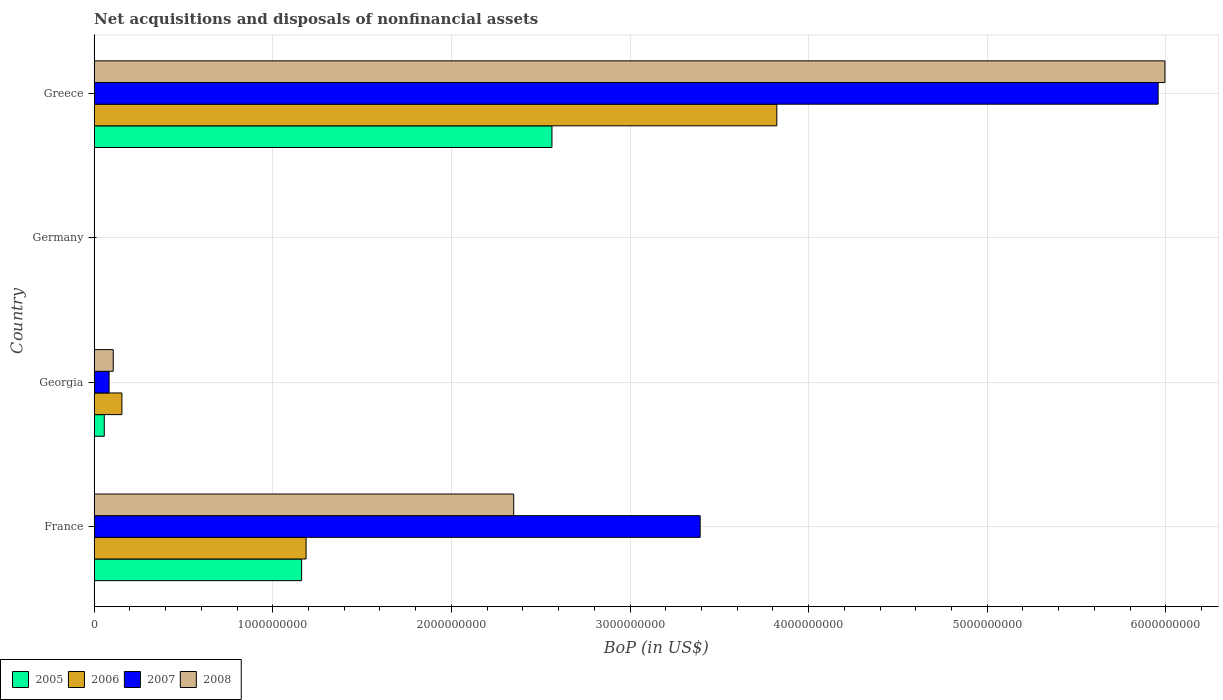How many different coloured bars are there?
Offer a very short reply. 4. Are the number of bars per tick equal to the number of legend labels?
Give a very brief answer. No. Are the number of bars on each tick of the Y-axis equal?
Your answer should be very brief. No. How many bars are there on the 1st tick from the top?
Ensure brevity in your answer.  4. What is the label of the 2nd group of bars from the top?
Make the answer very short. Germany. What is the Balance of Payments in 2007 in Germany?
Offer a very short reply. 0. Across all countries, what is the maximum Balance of Payments in 2008?
Offer a very short reply. 6.00e+09. What is the total Balance of Payments in 2008 in the graph?
Provide a succinct answer. 8.45e+09. What is the difference between the Balance of Payments in 2005 in Georgia and that in Greece?
Your response must be concise. -2.51e+09. What is the difference between the Balance of Payments in 2005 in Greece and the Balance of Payments in 2008 in Germany?
Offer a terse response. 2.56e+09. What is the average Balance of Payments in 2007 per country?
Offer a terse response. 2.36e+09. What is the difference between the Balance of Payments in 2007 and Balance of Payments in 2005 in France?
Offer a very short reply. 2.23e+09. What is the ratio of the Balance of Payments in 2007 in Georgia to that in Greece?
Ensure brevity in your answer.  0.01. Is the difference between the Balance of Payments in 2007 in Georgia and Greece greater than the difference between the Balance of Payments in 2005 in Georgia and Greece?
Offer a terse response. No. What is the difference between the highest and the second highest Balance of Payments in 2005?
Provide a succinct answer. 1.40e+09. What is the difference between the highest and the lowest Balance of Payments in 2005?
Your answer should be compact. 2.56e+09. In how many countries, is the Balance of Payments in 2007 greater than the average Balance of Payments in 2007 taken over all countries?
Ensure brevity in your answer.  2. Is the sum of the Balance of Payments in 2006 in Georgia and Greece greater than the maximum Balance of Payments in 2005 across all countries?
Keep it short and to the point. Yes. Is it the case that in every country, the sum of the Balance of Payments in 2008 and Balance of Payments in 2007 is greater than the sum of Balance of Payments in 2005 and Balance of Payments in 2006?
Your response must be concise. No. Is it the case that in every country, the sum of the Balance of Payments in 2007 and Balance of Payments in 2006 is greater than the Balance of Payments in 2008?
Make the answer very short. No. How many bars are there?
Your response must be concise. 12. Are all the bars in the graph horizontal?
Give a very brief answer. Yes. Are the values on the major ticks of X-axis written in scientific E-notation?
Your answer should be very brief. No. Does the graph contain grids?
Offer a terse response. Yes. How many legend labels are there?
Provide a short and direct response. 4. What is the title of the graph?
Your answer should be compact. Net acquisitions and disposals of nonfinancial assets. Does "2005" appear as one of the legend labels in the graph?
Provide a short and direct response. Yes. What is the label or title of the X-axis?
Your answer should be compact. BoP (in US$). What is the BoP (in US$) of 2005 in France?
Offer a very short reply. 1.16e+09. What is the BoP (in US$) in 2006 in France?
Provide a succinct answer. 1.19e+09. What is the BoP (in US$) of 2007 in France?
Your answer should be compact. 3.39e+09. What is the BoP (in US$) in 2008 in France?
Offer a terse response. 2.35e+09. What is the BoP (in US$) of 2005 in Georgia?
Offer a very short reply. 5.65e+07. What is the BoP (in US$) in 2006 in Georgia?
Offer a terse response. 1.55e+08. What is the BoP (in US$) in 2007 in Georgia?
Offer a very short reply. 8.34e+07. What is the BoP (in US$) of 2008 in Georgia?
Keep it short and to the point. 1.07e+08. What is the BoP (in US$) of 2005 in Germany?
Keep it short and to the point. 0. What is the BoP (in US$) in 2005 in Greece?
Your answer should be compact. 2.56e+09. What is the BoP (in US$) of 2006 in Greece?
Offer a terse response. 3.82e+09. What is the BoP (in US$) in 2007 in Greece?
Your response must be concise. 5.96e+09. What is the BoP (in US$) of 2008 in Greece?
Offer a very short reply. 6.00e+09. Across all countries, what is the maximum BoP (in US$) of 2005?
Your response must be concise. 2.56e+09. Across all countries, what is the maximum BoP (in US$) in 2006?
Make the answer very short. 3.82e+09. Across all countries, what is the maximum BoP (in US$) of 2007?
Provide a short and direct response. 5.96e+09. Across all countries, what is the maximum BoP (in US$) of 2008?
Offer a terse response. 6.00e+09. Across all countries, what is the minimum BoP (in US$) of 2006?
Give a very brief answer. 0. Across all countries, what is the minimum BoP (in US$) in 2007?
Provide a short and direct response. 0. What is the total BoP (in US$) of 2005 in the graph?
Your response must be concise. 3.78e+09. What is the total BoP (in US$) of 2006 in the graph?
Provide a short and direct response. 5.16e+09. What is the total BoP (in US$) in 2007 in the graph?
Provide a short and direct response. 9.43e+09. What is the total BoP (in US$) of 2008 in the graph?
Keep it short and to the point. 8.45e+09. What is the difference between the BoP (in US$) of 2005 in France and that in Georgia?
Provide a short and direct response. 1.10e+09. What is the difference between the BoP (in US$) of 2006 in France and that in Georgia?
Your answer should be very brief. 1.03e+09. What is the difference between the BoP (in US$) of 2007 in France and that in Georgia?
Ensure brevity in your answer.  3.31e+09. What is the difference between the BoP (in US$) in 2008 in France and that in Georgia?
Provide a succinct answer. 2.24e+09. What is the difference between the BoP (in US$) in 2005 in France and that in Greece?
Ensure brevity in your answer.  -1.40e+09. What is the difference between the BoP (in US$) of 2006 in France and that in Greece?
Ensure brevity in your answer.  -2.64e+09. What is the difference between the BoP (in US$) of 2007 in France and that in Greece?
Provide a succinct answer. -2.56e+09. What is the difference between the BoP (in US$) of 2008 in France and that in Greece?
Offer a very short reply. -3.65e+09. What is the difference between the BoP (in US$) of 2005 in Georgia and that in Greece?
Give a very brief answer. -2.51e+09. What is the difference between the BoP (in US$) of 2006 in Georgia and that in Greece?
Ensure brevity in your answer.  -3.67e+09. What is the difference between the BoP (in US$) of 2007 in Georgia and that in Greece?
Provide a short and direct response. -5.87e+09. What is the difference between the BoP (in US$) of 2008 in Georgia and that in Greece?
Give a very brief answer. -5.89e+09. What is the difference between the BoP (in US$) in 2005 in France and the BoP (in US$) in 2006 in Georgia?
Keep it short and to the point. 1.01e+09. What is the difference between the BoP (in US$) of 2005 in France and the BoP (in US$) of 2007 in Georgia?
Provide a short and direct response. 1.08e+09. What is the difference between the BoP (in US$) in 2005 in France and the BoP (in US$) in 2008 in Georgia?
Provide a short and direct response. 1.05e+09. What is the difference between the BoP (in US$) of 2006 in France and the BoP (in US$) of 2007 in Georgia?
Provide a short and direct response. 1.10e+09. What is the difference between the BoP (in US$) in 2006 in France and the BoP (in US$) in 2008 in Georgia?
Your answer should be very brief. 1.08e+09. What is the difference between the BoP (in US$) in 2007 in France and the BoP (in US$) in 2008 in Georgia?
Your answer should be very brief. 3.29e+09. What is the difference between the BoP (in US$) in 2005 in France and the BoP (in US$) in 2006 in Greece?
Offer a terse response. -2.66e+09. What is the difference between the BoP (in US$) of 2005 in France and the BoP (in US$) of 2007 in Greece?
Provide a succinct answer. -4.80e+09. What is the difference between the BoP (in US$) in 2005 in France and the BoP (in US$) in 2008 in Greece?
Your response must be concise. -4.83e+09. What is the difference between the BoP (in US$) in 2006 in France and the BoP (in US$) in 2007 in Greece?
Provide a short and direct response. -4.77e+09. What is the difference between the BoP (in US$) of 2006 in France and the BoP (in US$) of 2008 in Greece?
Your answer should be compact. -4.81e+09. What is the difference between the BoP (in US$) of 2007 in France and the BoP (in US$) of 2008 in Greece?
Offer a terse response. -2.60e+09. What is the difference between the BoP (in US$) of 2005 in Georgia and the BoP (in US$) of 2006 in Greece?
Give a very brief answer. -3.77e+09. What is the difference between the BoP (in US$) of 2005 in Georgia and the BoP (in US$) of 2007 in Greece?
Your response must be concise. -5.90e+09. What is the difference between the BoP (in US$) of 2005 in Georgia and the BoP (in US$) of 2008 in Greece?
Provide a succinct answer. -5.94e+09. What is the difference between the BoP (in US$) of 2006 in Georgia and the BoP (in US$) of 2007 in Greece?
Your answer should be very brief. -5.80e+09. What is the difference between the BoP (in US$) of 2006 in Georgia and the BoP (in US$) of 2008 in Greece?
Make the answer very short. -5.84e+09. What is the difference between the BoP (in US$) of 2007 in Georgia and the BoP (in US$) of 2008 in Greece?
Provide a succinct answer. -5.91e+09. What is the average BoP (in US$) of 2005 per country?
Make the answer very short. 9.45e+08. What is the average BoP (in US$) of 2006 per country?
Keep it short and to the point. 1.29e+09. What is the average BoP (in US$) of 2007 per country?
Your answer should be very brief. 2.36e+09. What is the average BoP (in US$) of 2008 per country?
Provide a succinct answer. 2.11e+09. What is the difference between the BoP (in US$) in 2005 and BoP (in US$) in 2006 in France?
Give a very brief answer. -2.51e+07. What is the difference between the BoP (in US$) in 2005 and BoP (in US$) in 2007 in France?
Keep it short and to the point. -2.23e+09. What is the difference between the BoP (in US$) in 2005 and BoP (in US$) in 2008 in France?
Offer a terse response. -1.19e+09. What is the difference between the BoP (in US$) in 2006 and BoP (in US$) in 2007 in France?
Provide a short and direct response. -2.21e+09. What is the difference between the BoP (in US$) in 2006 and BoP (in US$) in 2008 in France?
Your response must be concise. -1.16e+09. What is the difference between the BoP (in US$) of 2007 and BoP (in US$) of 2008 in France?
Ensure brevity in your answer.  1.04e+09. What is the difference between the BoP (in US$) in 2005 and BoP (in US$) in 2006 in Georgia?
Offer a very short reply. -9.86e+07. What is the difference between the BoP (in US$) in 2005 and BoP (in US$) in 2007 in Georgia?
Ensure brevity in your answer.  -2.69e+07. What is the difference between the BoP (in US$) in 2005 and BoP (in US$) in 2008 in Georgia?
Provide a succinct answer. -5.01e+07. What is the difference between the BoP (in US$) in 2006 and BoP (in US$) in 2007 in Georgia?
Offer a very short reply. 7.17e+07. What is the difference between the BoP (in US$) of 2006 and BoP (in US$) of 2008 in Georgia?
Keep it short and to the point. 4.85e+07. What is the difference between the BoP (in US$) in 2007 and BoP (in US$) in 2008 in Georgia?
Provide a short and direct response. -2.32e+07. What is the difference between the BoP (in US$) of 2005 and BoP (in US$) of 2006 in Greece?
Keep it short and to the point. -1.26e+09. What is the difference between the BoP (in US$) in 2005 and BoP (in US$) in 2007 in Greece?
Offer a very short reply. -3.39e+09. What is the difference between the BoP (in US$) in 2005 and BoP (in US$) in 2008 in Greece?
Make the answer very short. -3.43e+09. What is the difference between the BoP (in US$) in 2006 and BoP (in US$) in 2007 in Greece?
Offer a very short reply. -2.14e+09. What is the difference between the BoP (in US$) of 2006 and BoP (in US$) of 2008 in Greece?
Offer a terse response. -2.17e+09. What is the difference between the BoP (in US$) of 2007 and BoP (in US$) of 2008 in Greece?
Provide a succinct answer. -3.82e+07. What is the ratio of the BoP (in US$) of 2005 in France to that in Georgia?
Provide a short and direct response. 20.56. What is the ratio of the BoP (in US$) in 2006 in France to that in Georgia?
Make the answer very short. 7.65. What is the ratio of the BoP (in US$) of 2007 in France to that in Georgia?
Your answer should be very brief. 40.68. What is the ratio of the BoP (in US$) of 2008 in France to that in Georgia?
Your response must be concise. 22.03. What is the ratio of the BoP (in US$) of 2005 in France to that in Greece?
Provide a short and direct response. 0.45. What is the ratio of the BoP (in US$) in 2006 in France to that in Greece?
Offer a very short reply. 0.31. What is the ratio of the BoP (in US$) in 2007 in France to that in Greece?
Your answer should be very brief. 0.57. What is the ratio of the BoP (in US$) in 2008 in France to that in Greece?
Offer a very short reply. 0.39. What is the ratio of the BoP (in US$) of 2005 in Georgia to that in Greece?
Provide a succinct answer. 0.02. What is the ratio of the BoP (in US$) of 2006 in Georgia to that in Greece?
Your answer should be very brief. 0.04. What is the ratio of the BoP (in US$) of 2007 in Georgia to that in Greece?
Keep it short and to the point. 0.01. What is the ratio of the BoP (in US$) of 2008 in Georgia to that in Greece?
Your answer should be very brief. 0.02. What is the difference between the highest and the second highest BoP (in US$) in 2005?
Offer a terse response. 1.40e+09. What is the difference between the highest and the second highest BoP (in US$) of 2006?
Give a very brief answer. 2.64e+09. What is the difference between the highest and the second highest BoP (in US$) of 2007?
Your response must be concise. 2.56e+09. What is the difference between the highest and the second highest BoP (in US$) in 2008?
Offer a terse response. 3.65e+09. What is the difference between the highest and the lowest BoP (in US$) in 2005?
Your answer should be compact. 2.56e+09. What is the difference between the highest and the lowest BoP (in US$) in 2006?
Your answer should be compact. 3.82e+09. What is the difference between the highest and the lowest BoP (in US$) of 2007?
Offer a very short reply. 5.96e+09. What is the difference between the highest and the lowest BoP (in US$) of 2008?
Your response must be concise. 6.00e+09. 